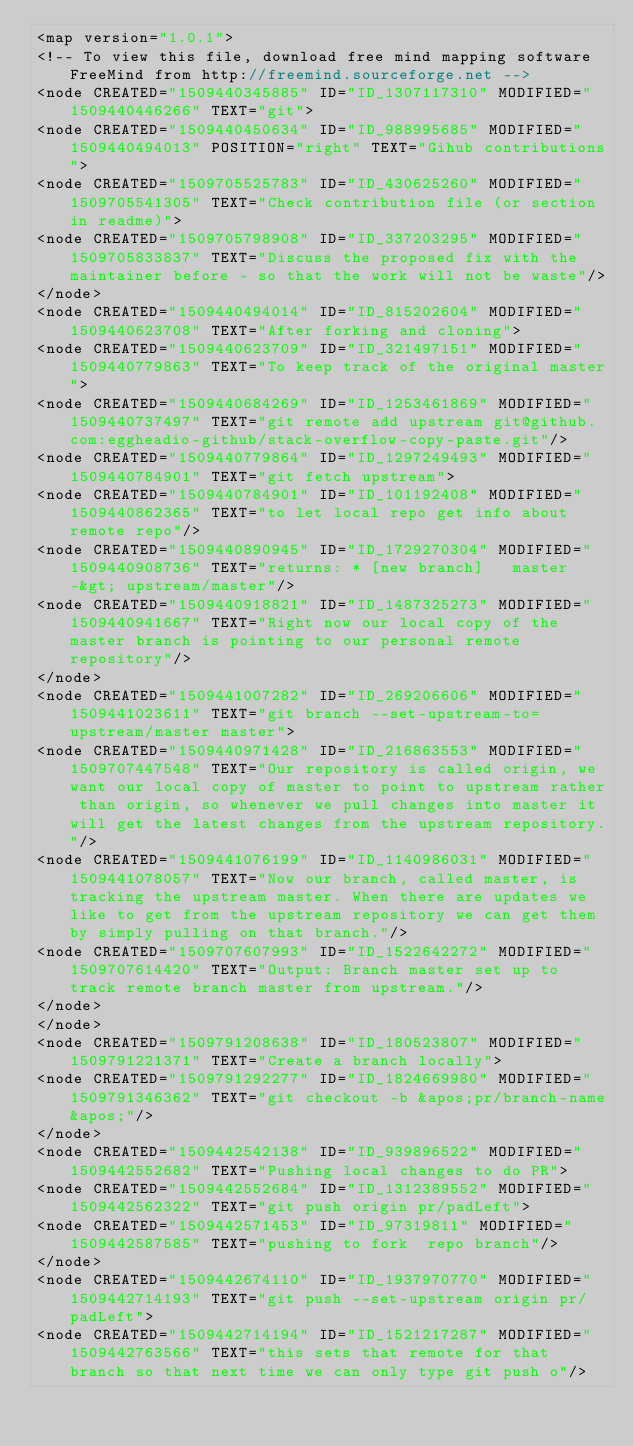<code> <loc_0><loc_0><loc_500><loc_500><_ObjectiveC_><map version="1.0.1">
<!-- To view this file, download free mind mapping software FreeMind from http://freemind.sourceforge.net -->
<node CREATED="1509440345885" ID="ID_1307117310" MODIFIED="1509440446266" TEXT="git">
<node CREATED="1509440450634" ID="ID_988995685" MODIFIED="1509440494013" POSITION="right" TEXT="Gihub contributions">
<node CREATED="1509705525783" ID="ID_430625260" MODIFIED="1509705541305" TEXT="Check contribution file (or section in readme)">
<node CREATED="1509705798908" ID="ID_337203295" MODIFIED="1509705833837" TEXT="Discuss the proposed fix with the maintainer before - so that the work will not be waste"/>
</node>
<node CREATED="1509440494014" ID="ID_815202604" MODIFIED="1509440623708" TEXT="After forking and cloning">
<node CREATED="1509440623709" ID="ID_321497151" MODIFIED="1509440779863" TEXT="To keep track of the original master">
<node CREATED="1509440684269" ID="ID_1253461869" MODIFIED="1509440737497" TEXT="git remote add upstream git@github.com:eggheadio-github/stack-overflow-copy-paste.git"/>
<node CREATED="1509440779864" ID="ID_1297249493" MODIFIED="1509440784901" TEXT="git fetch upstream">
<node CREATED="1509440784901" ID="ID_101192408" MODIFIED="1509440862365" TEXT="to let local repo get info about remote repo"/>
<node CREATED="1509440890945" ID="ID_1729270304" MODIFIED="1509440908736" TEXT="returns: * [new branch]   master   -&gt; upstream/master"/>
<node CREATED="1509440918821" ID="ID_1487325273" MODIFIED="1509440941667" TEXT="Right now our local copy of the master branch is pointing to our personal remote repository"/>
</node>
<node CREATED="1509441007282" ID="ID_269206606" MODIFIED="1509441023611" TEXT="git branch --set-upstream-to=upstream/master master">
<node CREATED="1509440971428" ID="ID_216863553" MODIFIED="1509707447548" TEXT="Our repository is called origin, we want our local copy of master to point to upstream rather than origin, so whenever we pull changes into master it will get the latest changes from the upstream repository."/>
<node CREATED="1509441076199" ID="ID_1140986031" MODIFIED="1509441078057" TEXT="Now our branch, called master, is tracking the upstream master. When there are updates we like to get from the upstream repository we can get them by simply pulling on that branch."/>
<node CREATED="1509707607993" ID="ID_1522642272" MODIFIED="1509707614420" TEXT="Output: Branch master set up to track remote branch master from upstream."/>
</node>
</node>
<node CREATED="1509791208638" ID="ID_180523807" MODIFIED="1509791221371" TEXT="Create a branch locally">
<node CREATED="1509791292277" ID="ID_1824669980" MODIFIED="1509791346362" TEXT="git checkout -b &apos;pr/branch-name&apos;"/>
</node>
<node CREATED="1509442542138" ID="ID_939896522" MODIFIED="1509442552682" TEXT="Pushing local changes to do PR">
<node CREATED="1509442552684" ID="ID_1312389552" MODIFIED="1509442562322" TEXT="git push origin pr/padLeft">
<node CREATED="1509442571453" ID="ID_97319811" MODIFIED="1509442587585" TEXT="pushing to fork  repo branch"/>
</node>
<node CREATED="1509442674110" ID="ID_1937970770" MODIFIED="1509442714193" TEXT="git push --set-upstream origin pr/padLeft">
<node CREATED="1509442714194" ID="ID_1521217287" MODIFIED="1509442763566" TEXT="this sets that remote for that branch so that next time we can only type git push o"/></code> 